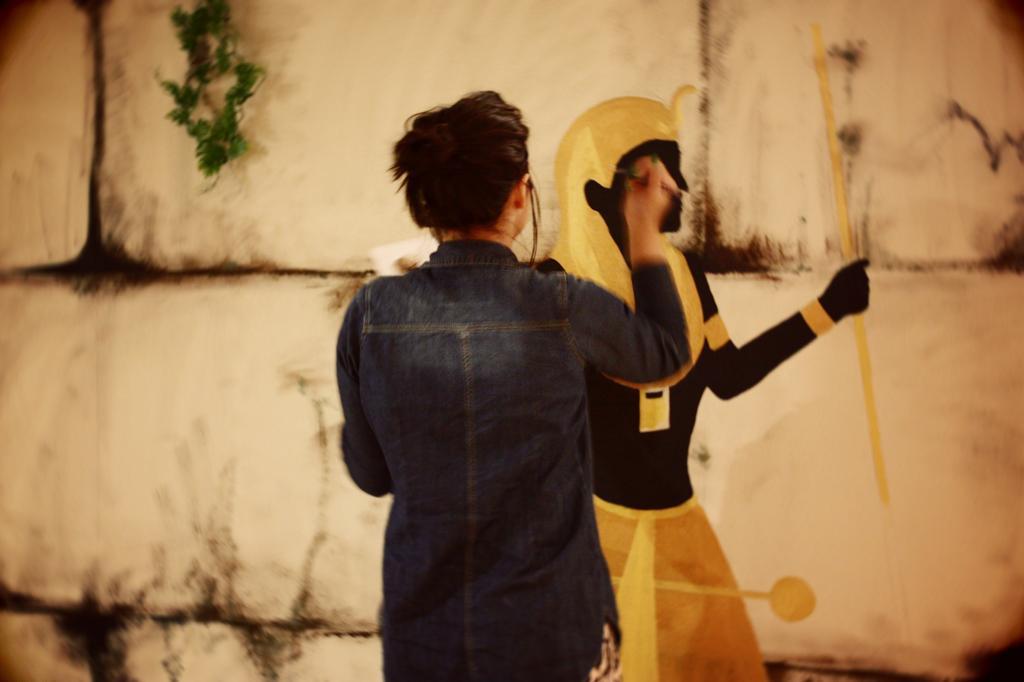In one or two sentences, can you explain what this image depicts? In this picture there is a person standing and painting on the wall and we can see green leaves. 